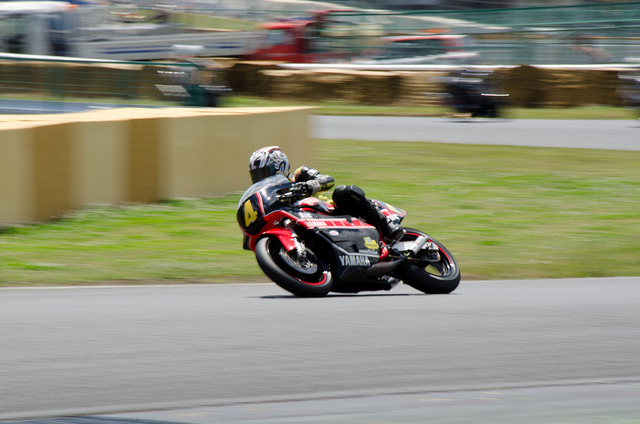<image>What computer company is on the black bike? It is uncertain what computer company is on the black bike, it could be Apple or Yamaha. What computer company is on the black bike? I don't know which computer company is on the black bike. It can be seen 'apple' or 'yamaha'. 